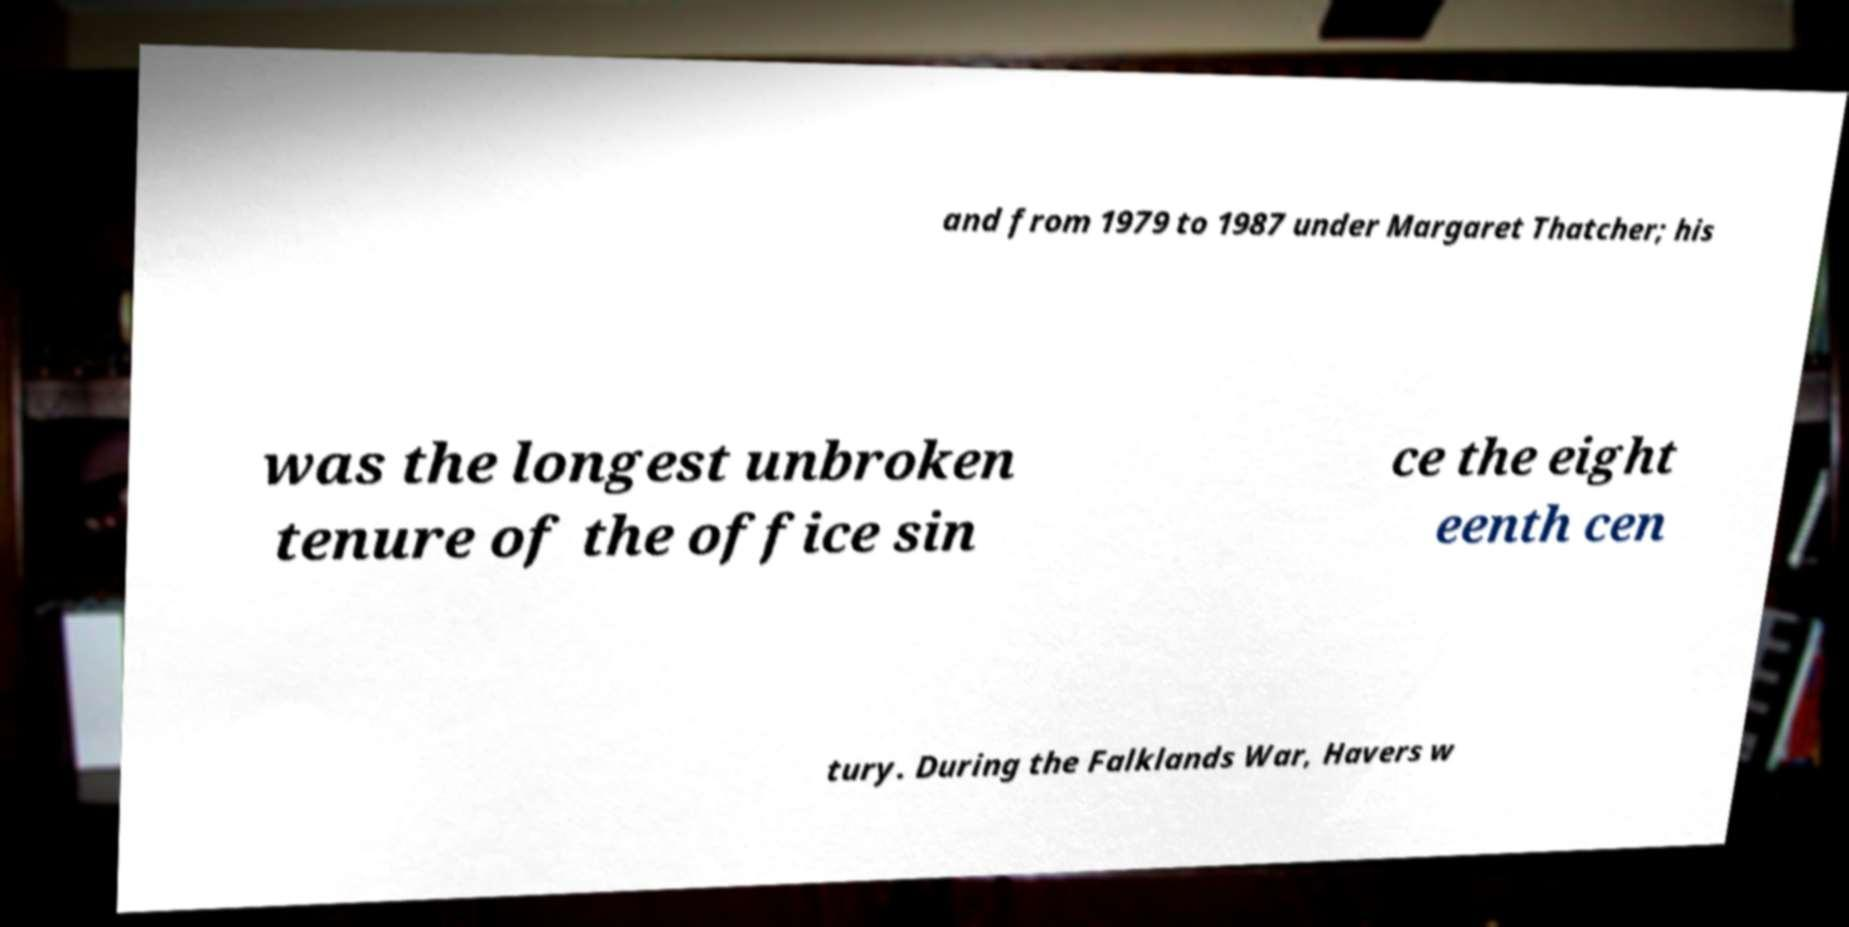Could you extract and type out the text from this image? and from 1979 to 1987 under Margaret Thatcher; his was the longest unbroken tenure of the office sin ce the eight eenth cen tury. During the Falklands War, Havers w 